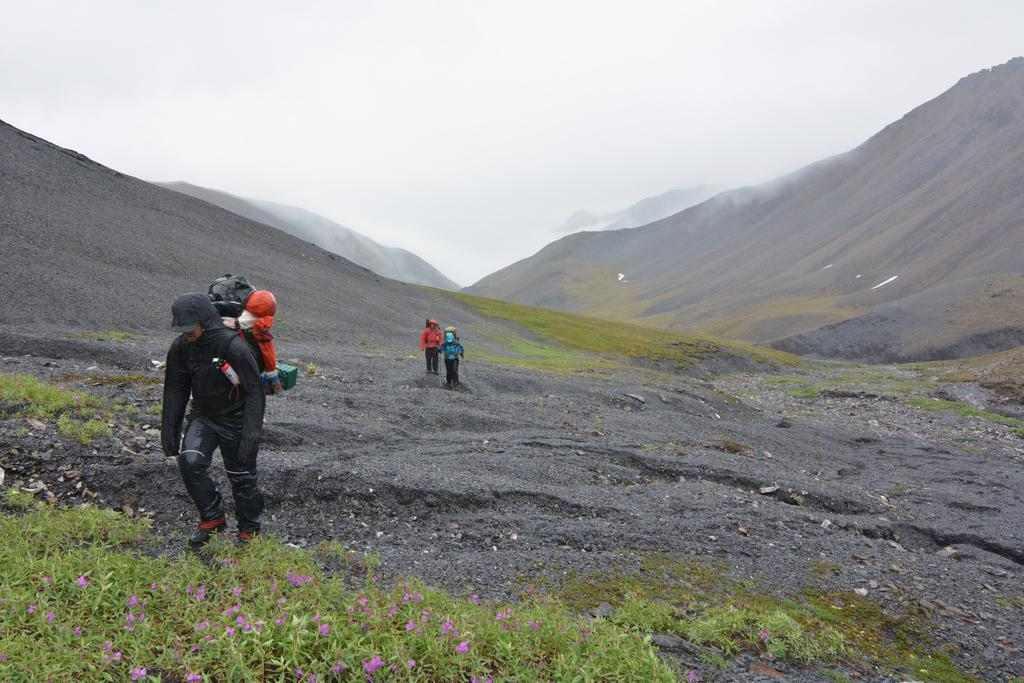How many people are in the image? There are three persons in the image. What are the persons wearing? The persons are wearing bags. Where are the persons located in the image? The persons are walking on a mountain. What can be seen in the background of the image? There are mountains visible in the background. What type of vegetation is present in the image? There are plants in the bottom left of the image. What type of mask is the person wearing in the image? There is no mask visible on any of the persons in the image. What flavor of oatmeal is the person eating in the image? There is no oatmeal or eating activity depicted in the image. 